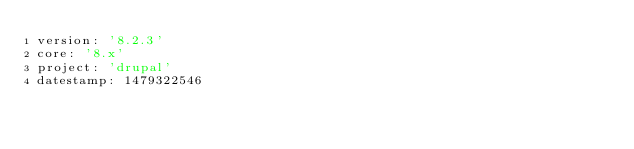Convert code to text. <code><loc_0><loc_0><loc_500><loc_500><_YAML_>version: '8.2.3'
core: '8.x'
project: 'drupal'
datestamp: 1479322546
</code> 